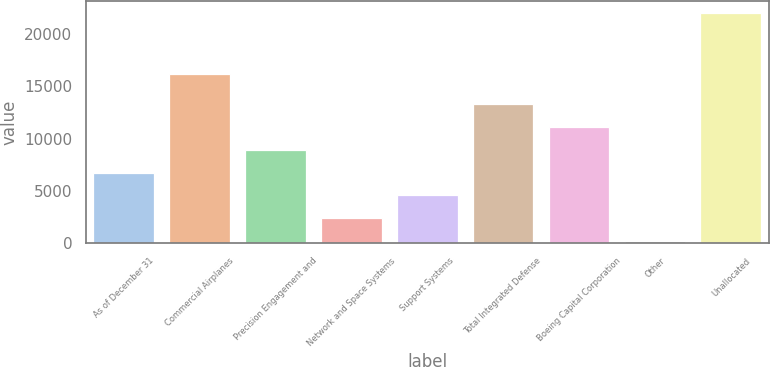<chart> <loc_0><loc_0><loc_500><loc_500><bar_chart><fcel>As of December 31<fcel>Commercial Airplanes<fcel>Precision Engagement and<fcel>Network and Space Systems<fcel>Support Systems<fcel>Total Integrated Defense<fcel>Boeing Capital Corporation<fcel>Other<fcel>Unallocated<nl><fcel>6762.3<fcel>16151<fcel>8948.4<fcel>2390.1<fcel>4576.2<fcel>13320.6<fcel>11134.5<fcel>204<fcel>22065<nl></chart> 